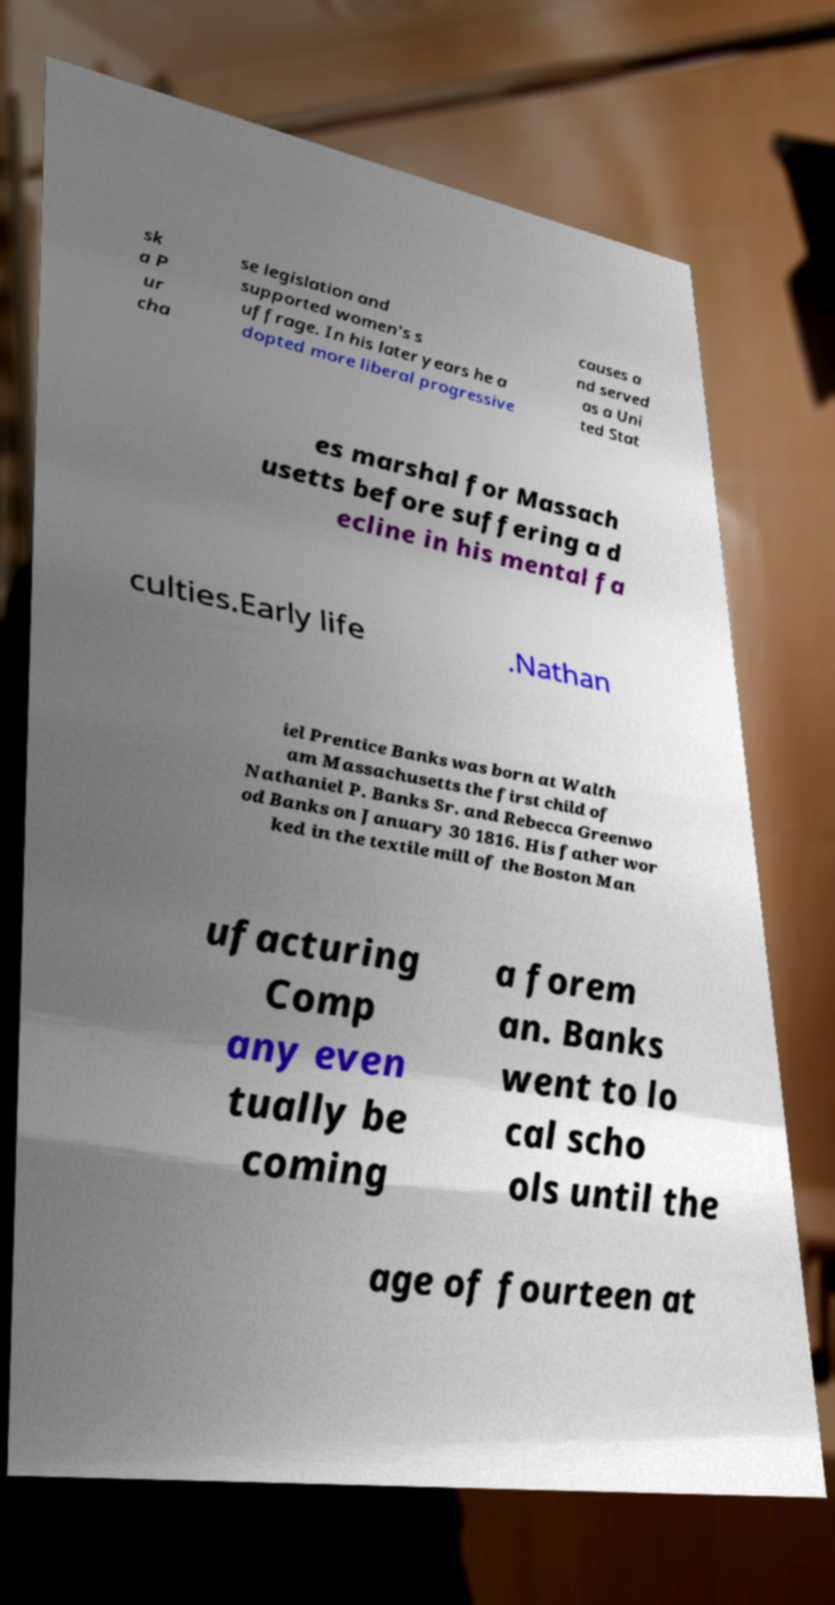What messages or text are displayed in this image? I need them in a readable, typed format. sk a P ur cha se legislation and supported women's s uffrage. In his later years he a dopted more liberal progressive causes a nd served as a Uni ted Stat es marshal for Massach usetts before suffering a d ecline in his mental fa culties.Early life .Nathan iel Prentice Banks was born at Walth am Massachusetts the first child of Nathaniel P. Banks Sr. and Rebecca Greenwo od Banks on January 30 1816. His father wor ked in the textile mill of the Boston Man ufacturing Comp any even tually be coming a forem an. Banks went to lo cal scho ols until the age of fourteen at 